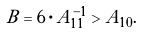<formula> <loc_0><loc_0><loc_500><loc_500>B = 6 \cdot A _ { 1 1 } ^ { - 1 } > A _ { 1 0 } .</formula> 